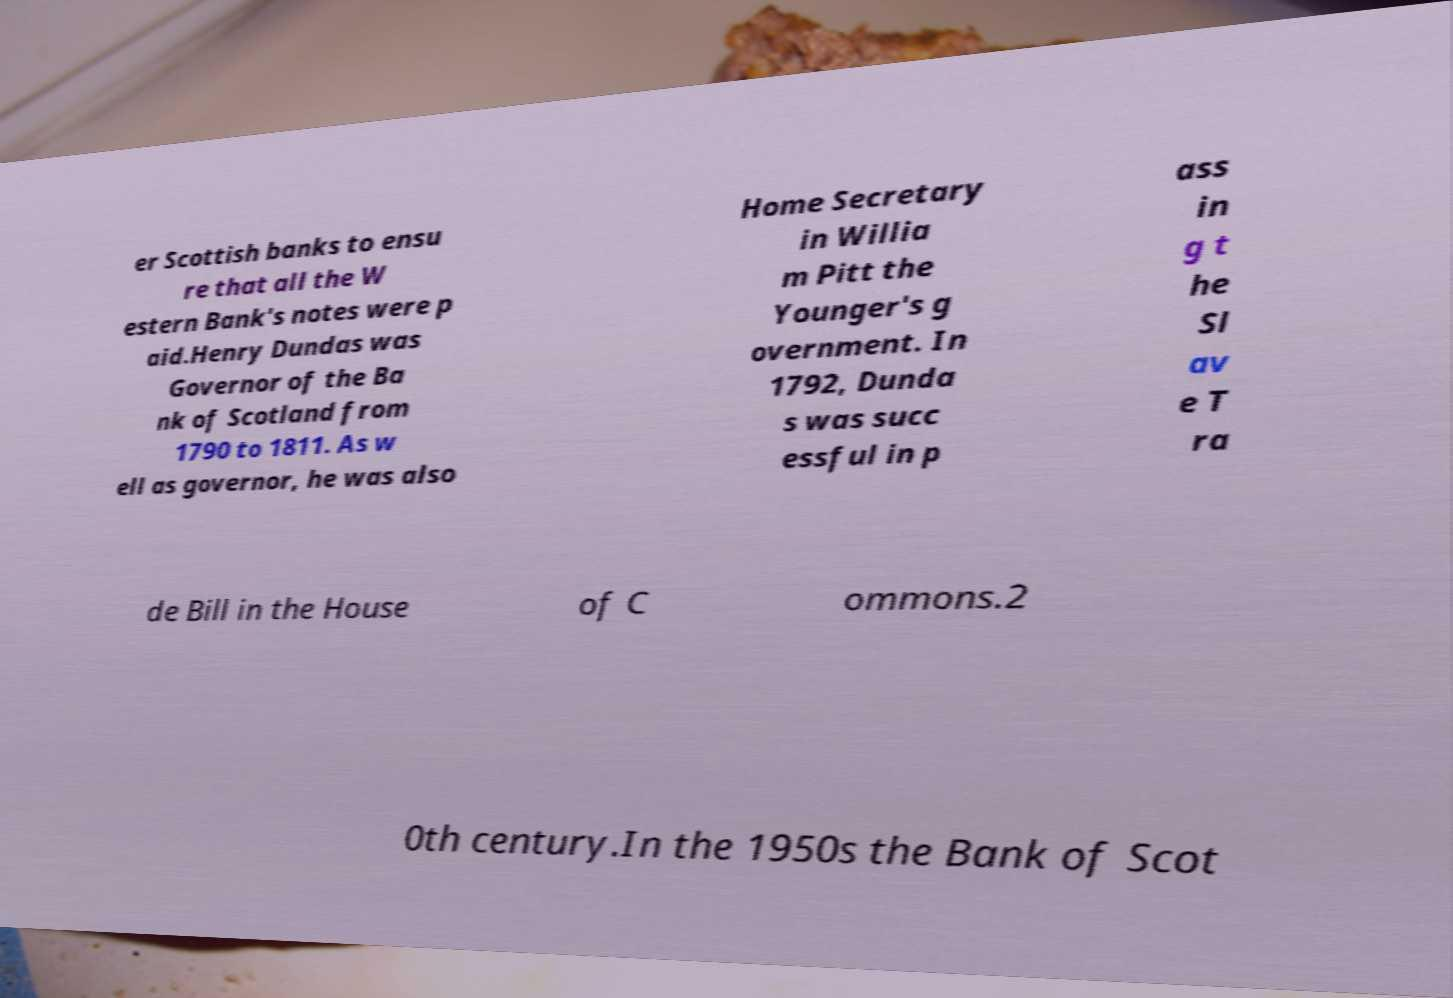Please read and relay the text visible in this image. What does it say? er Scottish banks to ensu re that all the W estern Bank's notes were p aid.Henry Dundas was Governor of the Ba nk of Scotland from 1790 to 1811. As w ell as governor, he was also Home Secretary in Willia m Pitt the Younger's g overnment. In 1792, Dunda s was succ essful in p ass in g t he Sl av e T ra de Bill in the House of C ommons.2 0th century.In the 1950s the Bank of Scot 